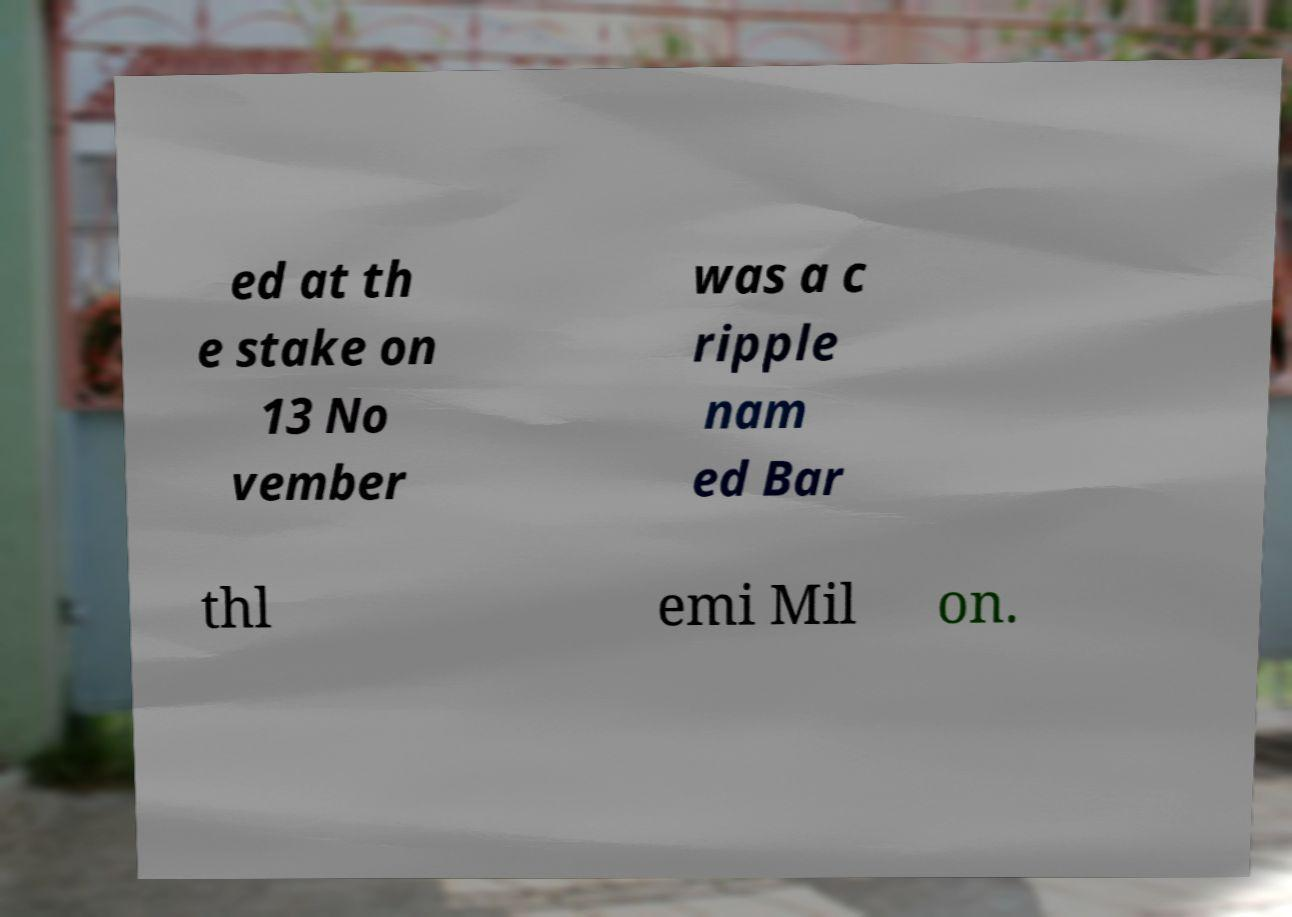There's text embedded in this image that I need extracted. Can you transcribe it verbatim? ed at th e stake on 13 No vember was a c ripple nam ed Bar thl emi Mil on. 